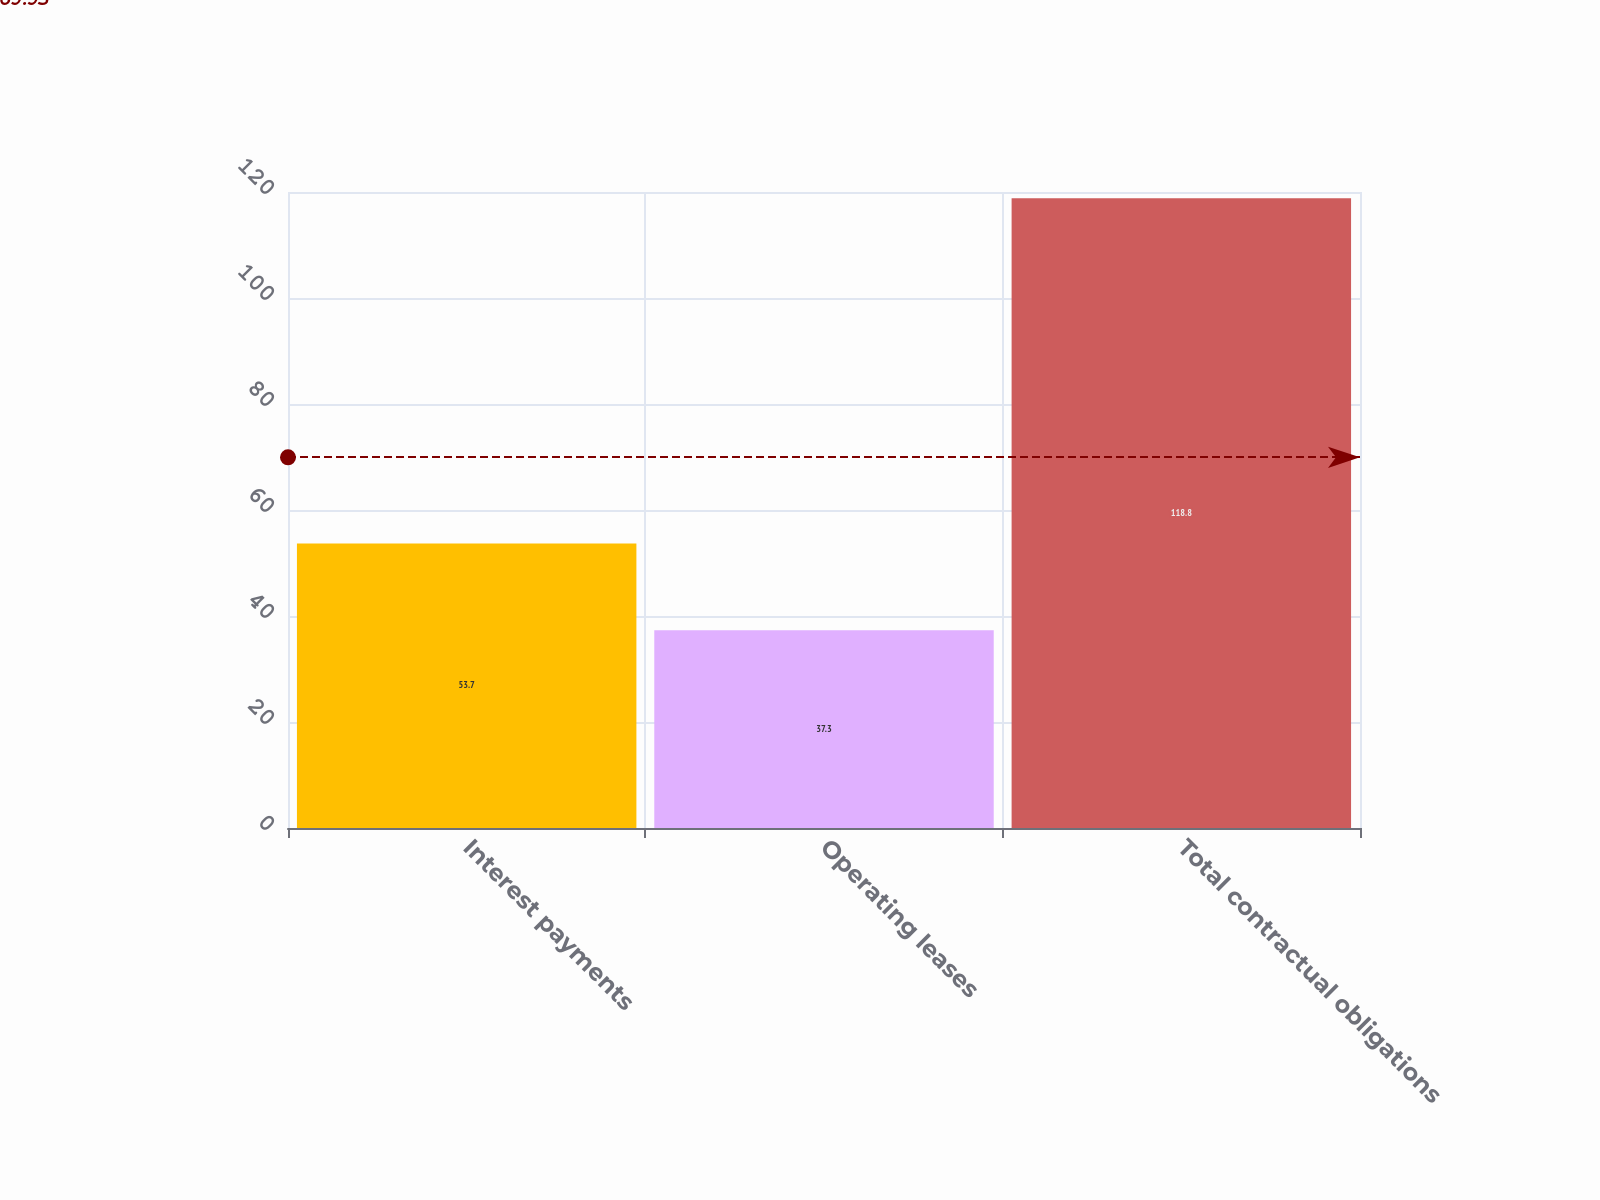Convert chart to OTSL. <chart><loc_0><loc_0><loc_500><loc_500><bar_chart><fcel>Interest payments<fcel>Operating leases<fcel>Total contractual obligations<nl><fcel>53.7<fcel>37.3<fcel>118.8<nl></chart> 